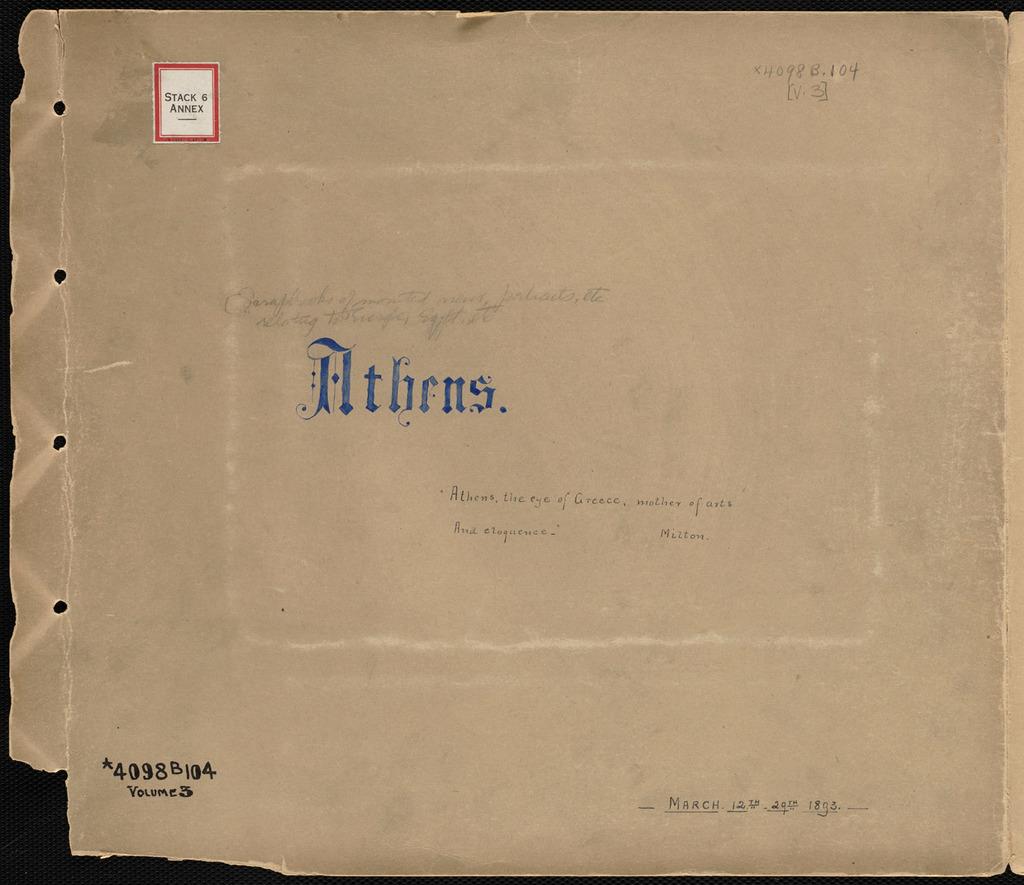What year is written on it?
Offer a terse response. 1803. What is the word on the middle of the page?
Provide a short and direct response. Athens. 